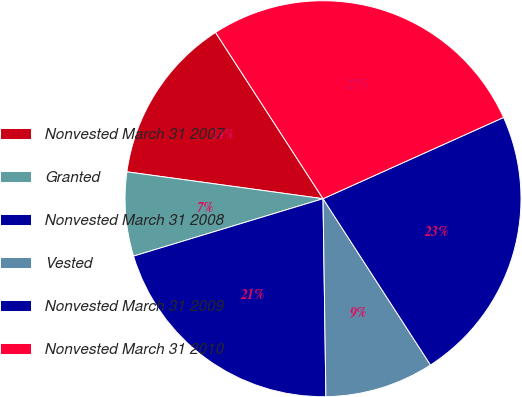<chart> <loc_0><loc_0><loc_500><loc_500><pie_chart><fcel>Nonvested March 31 2007<fcel>Granted<fcel>Nonvested March 31 2008<fcel>Vested<fcel>Nonvested March 31 2009<fcel>Nonvested March 31 2010<nl><fcel>13.7%<fcel>6.85%<fcel>20.55%<fcel>8.9%<fcel>22.6%<fcel>27.4%<nl></chart> 